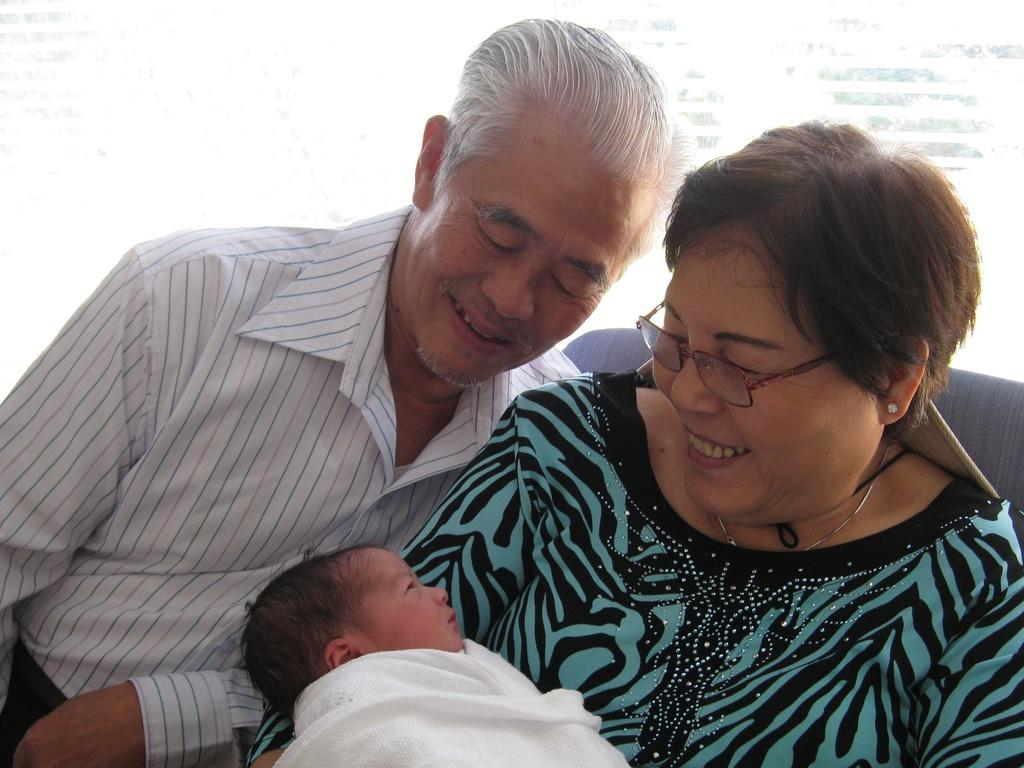How many people are in the image? There are two persons in the image. What are the two persons doing in the image? The two persons are sitting. What are the two persons holding in the image? The two persons are holding a baby. What type of story is the baby telling in the image? There is no indication in the image that the baby is telling a story, as babies do not have the ability to tell stories. 